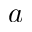Convert formula to latex. <formula><loc_0><loc_0><loc_500><loc_500>a</formula> 